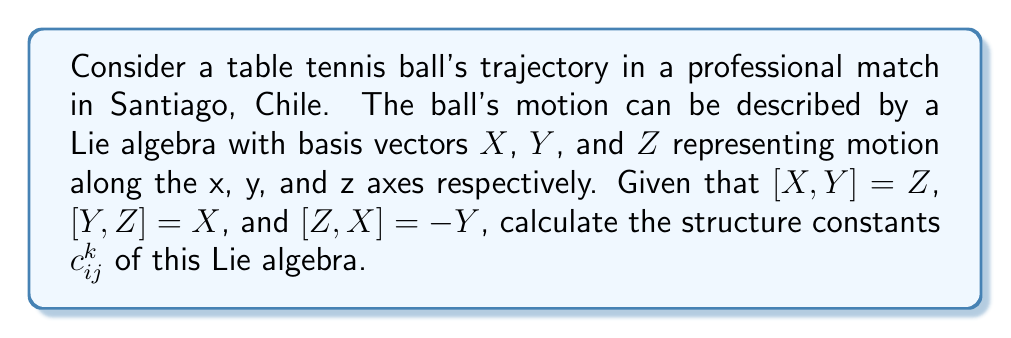Help me with this question. To solve this problem, we need to understand the concept of structure constants in Lie algebras and how they relate to the given commutation relations.

1) In a Lie algebra, the structure constants $c_{ij}^k$ are defined by the equation:

   $[X_i, X_j] = \sum_k c_{ij}^k X_k$

   where $X_i$, $X_j$, and $X_k$ are basis vectors of the Lie algebra.

2) From the given commutation relations, we can identify:

   $[X,Y] = Z$
   $[Y,Z] = X$
   $[Z,X] = -Y$

3) Let's assign indices to our basis vectors:
   $X_1 = X$, $X_2 = Y$, $X_3 = Z$

4) Now, we can write out the structure constants:

   For $[X,Y] = Z$:  $c_{12}^3 = 1$, $c_{12}^1 = c_{12}^2 = 0$
   
   For $[Y,Z] = X$:  $c_{23}^1 = 1$, $c_{23}^2 = c_{23}^3 = 0$
   
   For $[Z,X] = -Y$: $c_{31}^2 = -1$, $c_{31}^1 = c_{31}^3 = 0$

5) The remaining structure constants can be determined using the properties of Lie algebras:

   $c_{ij}^k = -c_{ji}^k$ (antisymmetry)
   $c_{ii}^k = 0$ (for all $i$ and $k$)

6) Applying these properties:

   $c_{21}^3 = -1$, $c_{32}^1 = -1$, $c_{13}^2 = 1$

   All other structure constants are zero.
Answer: The non-zero structure constants are:

$c_{12}^3 = 1$, $c_{23}^1 = 1$, $c_{31}^2 = -1$
$c_{21}^3 = -1$, $c_{32}^1 = -1$, $c_{13}^2 = 1$

All other $c_{ij}^k = 0$. 